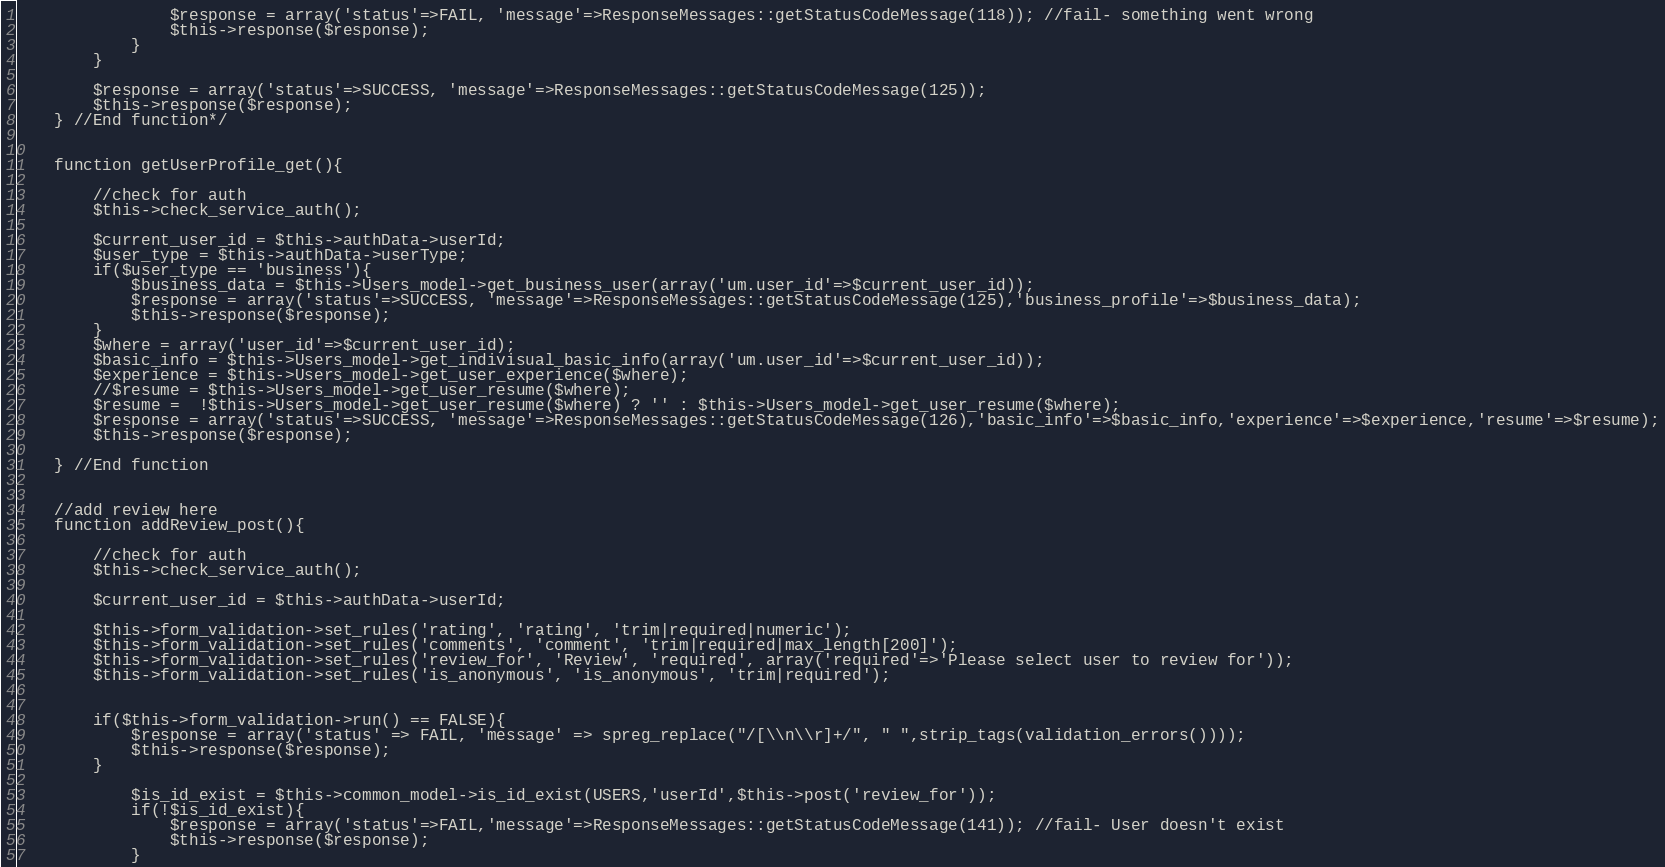Convert code to text. <code><loc_0><loc_0><loc_500><loc_500><_PHP_>                $response = array('status'=>FAIL, 'message'=>ResponseMessages::getStatusCodeMessage(118)); //fail- something went wrong
                $this->response($response); 
            }   
        } 

        $response = array('status'=>SUCCESS, 'message'=>ResponseMessages::getStatusCodeMessage(125));
        $this->response($response);
    } //End function*/


    function getUserProfile_get(){

        //check for auth
        $this->check_service_auth();

        $current_user_id = $this->authData->userId;
        $user_type = $this->authData->userType;
        if($user_type == 'business'){
            $business_data = $this->Users_model->get_business_user(array('um.user_id'=>$current_user_id));
            $response = array('status'=>SUCCESS, 'message'=>ResponseMessages::getStatusCodeMessage(125),'business_profile'=>$business_data);
            $this->response($response); 
        }
        $where = array('user_id'=>$current_user_id);
        $basic_info = $this->Users_model->get_indivisual_basic_info(array('um.user_id'=>$current_user_id));
        $experience = $this->Users_model->get_user_experience($where);
        //$resume = $this->Users_model->get_user_resume($where);
        $resume =  !$this->Users_model->get_user_resume($where) ? '' : $this->Users_model->get_user_resume($where);
        $response = array('status'=>SUCCESS, 'message'=>ResponseMessages::getStatusCodeMessage(126),'basic_info'=>$basic_info,'experience'=>$experience,'resume'=>$resume);
        $this->response($response); 
    
    } //End function


    //add review here
    function addReview_post(){

        //check for auth
        $this->check_service_auth();

        $current_user_id = $this->authData->userId;
        
        $this->form_validation->set_rules('rating', 'rating', 'trim|required|numeric');
        $this->form_validation->set_rules('comments', 'comment', 'trim|required|max_length[200]');
        $this->form_validation->set_rules('review_for', 'Review', 'required', array('required'=>'Please select user to review for'));
        $this->form_validation->set_rules('is_anonymous', 'is_anonymous', 'trim|required');
        
        
        if($this->form_validation->run() == FALSE){
            $response = array('status' => FAIL, 'message' => spreg_replace("/[\\n\\r]+/", " ",strip_tags(validation_errors())));
            $this->response($response); 
        }
        
            $is_id_exist = $this->common_model->is_id_exist(USERS,'userId',$this->post('review_for'));
            if(!$is_id_exist){
                $response = array('status'=>FAIL,'message'=>ResponseMessages::getStatusCodeMessage(141)); //fail- User doesn't exist
                $this->response($response); 
            }
</code> 